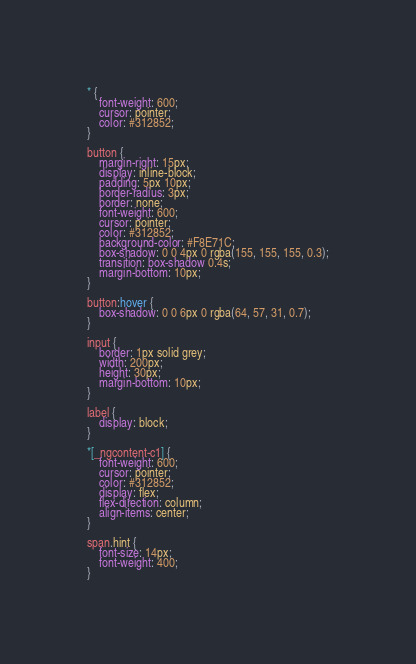<code> <loc_0><loc_0><loc_500><loc_500><_CSS_>* {
    font-weight: 600;
    cursor: pointer;
    color: #312852;
}

button {
    margin-right: 15px;
    display: inline-block;
    padding: 5px 10px;
    border-radius: 3px;
    border: none;
    font-weight: 600;
    cursor: pointer;
    color: #312852;
    background-color: #F8E71C;
    box-shadow: 0 0 4px 0 rgba(155, 155, 155, 0.3);
    transition: box-shadow 0.4s;
    margin-bottom: 10px;
}

button:hover {
    box-shadow: 0 0 6px 0 rgba(64, 57, 31, 0.7);
}

input {
    border: 1px solid grey;
    width: 200px;
    height: 30px;
    margin-bottom: 10px;
}

label {
    display: block;
}

*[_ngcontent-c1] {
    font-weight: 600;
    cursor: pointer;
    color: #312852;
    display: flex;
    flex-direction: column;
    align-items: center;
}

span.hint {
    font-size: 14px;
    font-weight: 400;
}</code> 